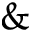<formula> <loc_0><loc_0><loc_500><loc_500>\&</formula> 